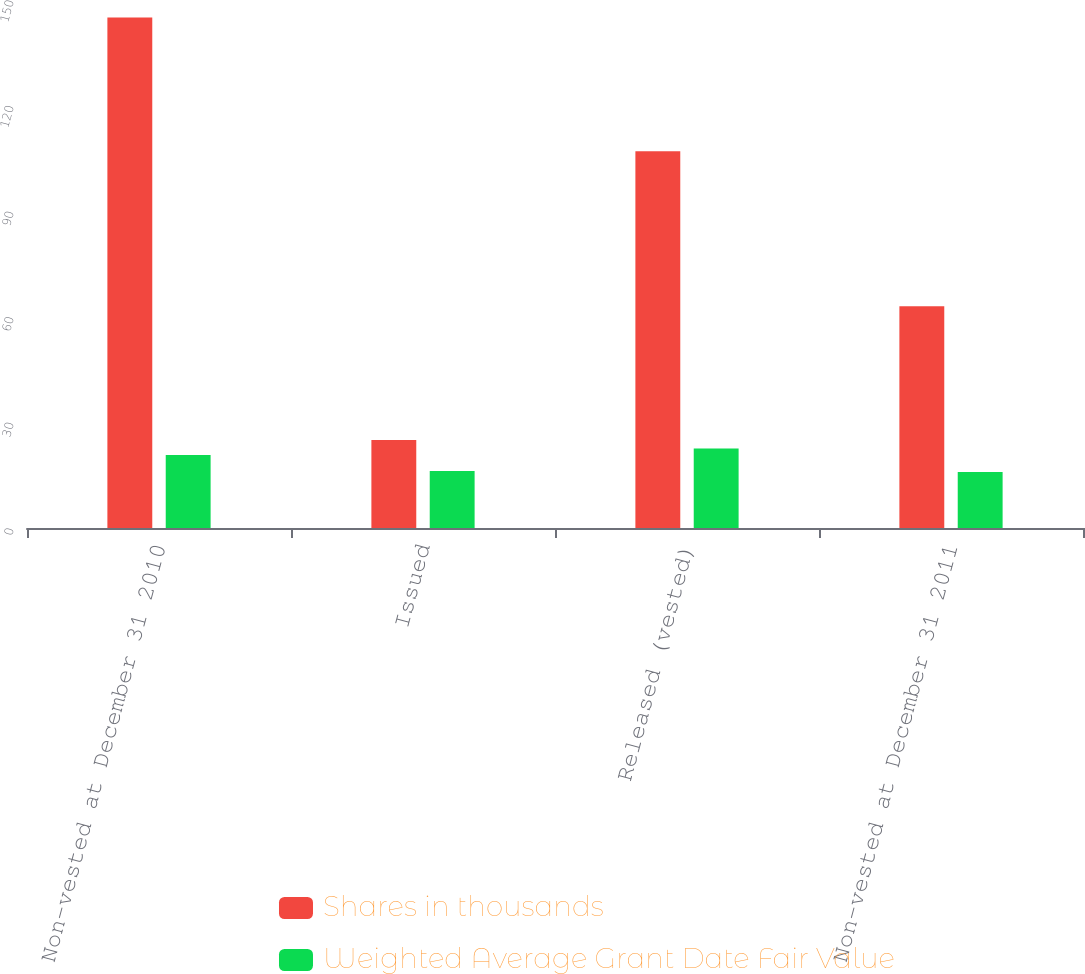<chart> <loc_0><loc_0><loc_500><loc_500><stacked_bar_chart><ecel><fcel>Non-vested at December 31 2010<fcel>Issued<fcel>Released (vested)<fcel>Non-vested at December 31 2011<nl><fcel>Shares in thousands<fcel>145<fcel>25<fcel>107<fcel>63<nl><fcel>Weighted Average Grant Date Fair Value<fcel>20.75<fcel>16.2<fcel>22.58<fcel>15.89<nl></chart> 